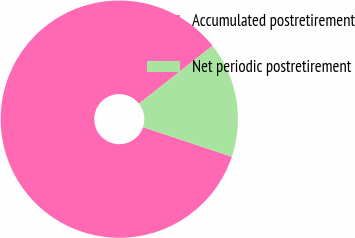Convert chart. <chart><loc_0><loc_0><loc_500><loc_500><pie_chart><fcel>Accumulated postretirement<fcel>Net periodic postretirement<nl><fcel>84.25%<fcel>15.75%<nl></chart> 